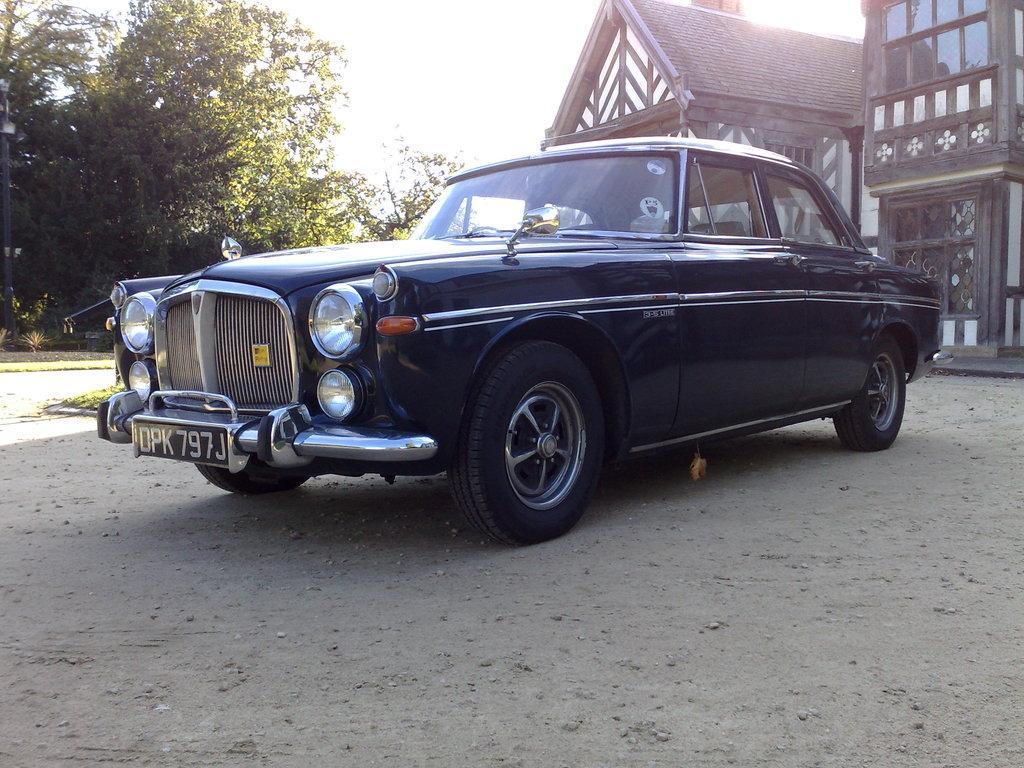Please provide a concise description of this image. In this picture we can observe a car on the land which is in black color. On the right side there are houses. We can observe trees on the left side. In the background there is a sky. 